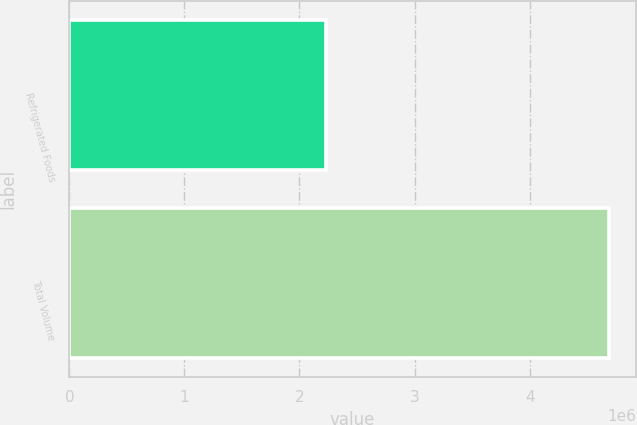Convert chart. <chart><loc_0><loc_0><loc_500><loc_500><bar_chart><fcel>Refrigerated Foods<fcel>Total Volume<nl><fcel>2.2348e+06<fcel>4.69003e+06<nl></chart> 